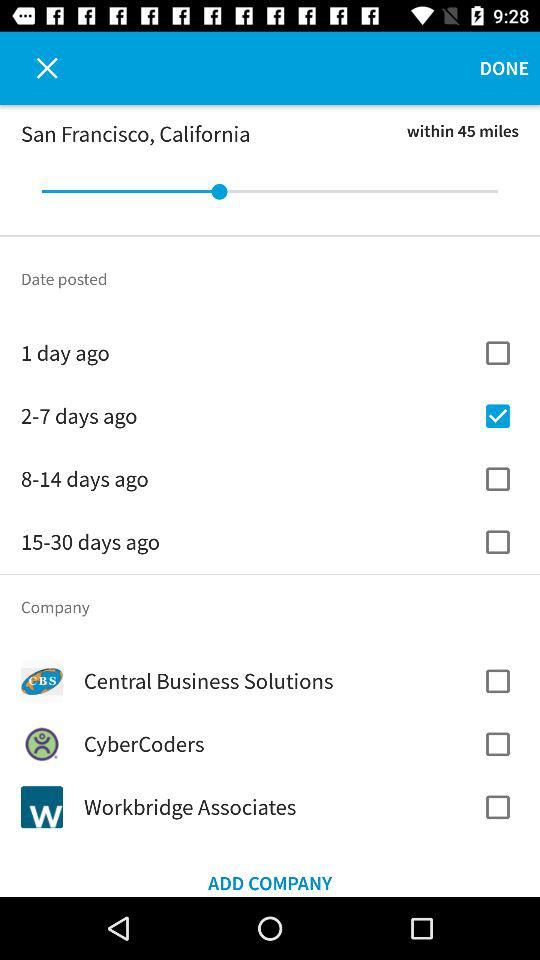What is the city name? The city name is San Francisco. 